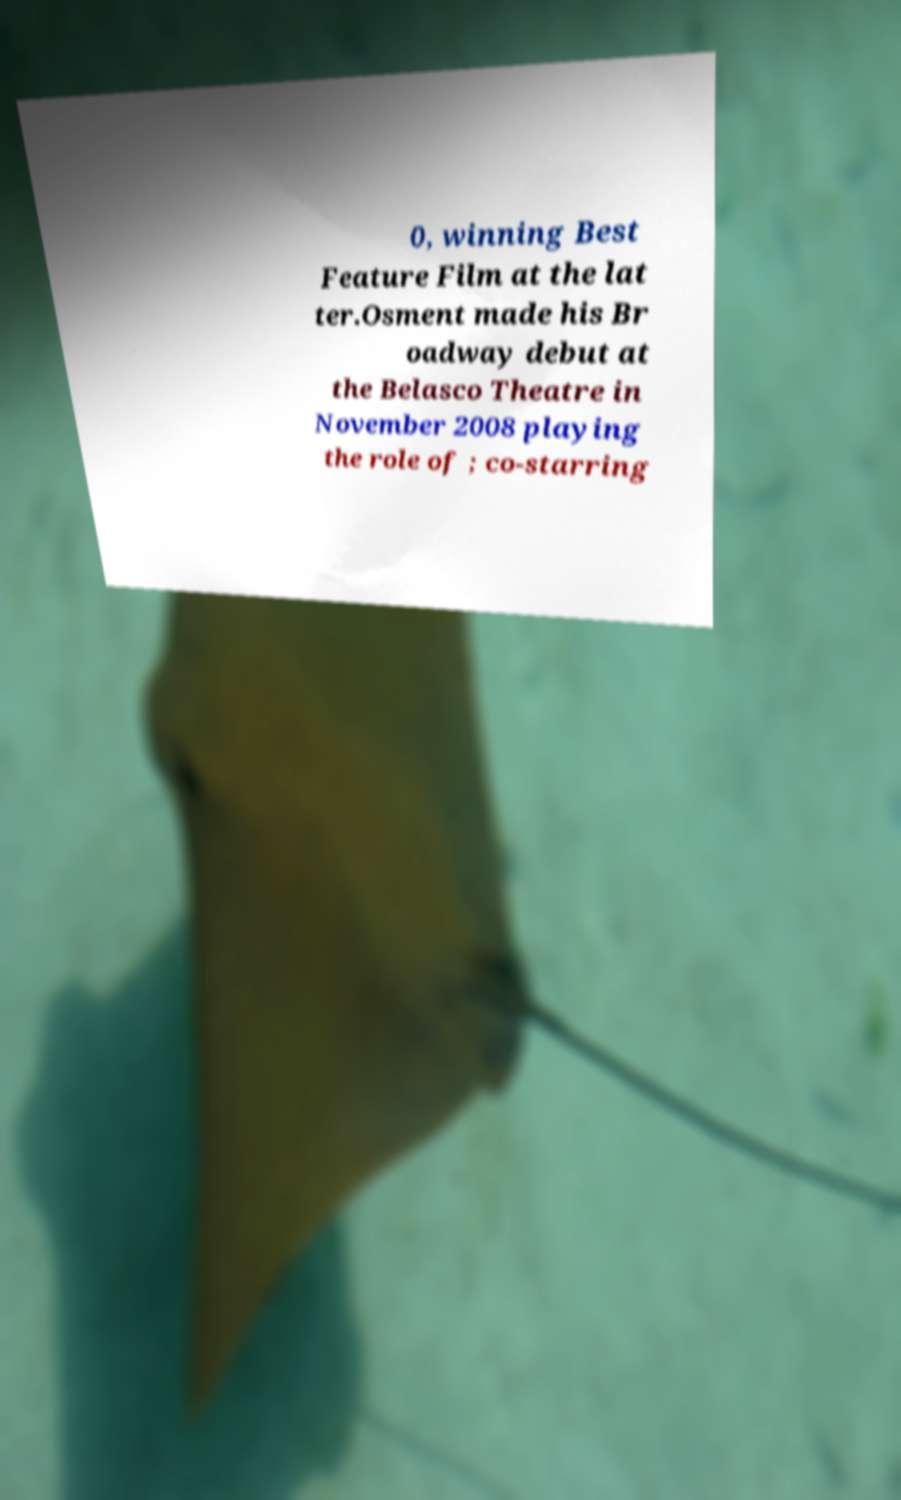Could you assist in decoding the text presented in this image and type it out clearly? 0, winning Best Feature Film at the lat ter.Osment made his Br oadway debut at the Belasco Theatre in November 2008 playing the role of ; co-starring 